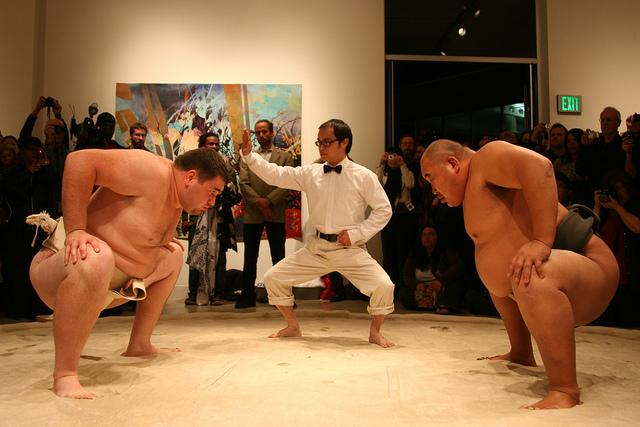This activity is most associated with which people group? sumo 